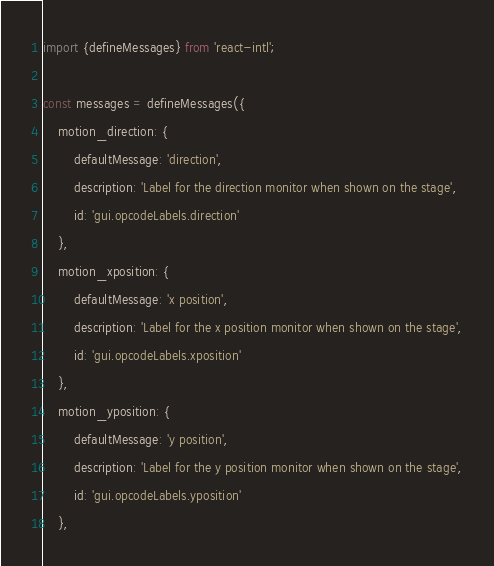<code> <loc_0><loc_0><loc_500><loc_500><_JavaScript_>import {defineMessages} from 'react-intl';

const messages = defineMessages({
    motion_direction: {
        defaultMessage: 'direction',
        description: 'Label for the direction monitor when shown on the stage',
        id: 'gui.opcodeLabels.direction'
    },
    motion_xposition: {
        defaultMessage: 'x position',
        description: 'Label for the x position monitor when shown on the stage',
        id: 'gui.opcodeLabels.xposition'
    },
    motion_yposition: {
        defaultMessage: 'y position',
        description: 'Label for the y position monitor when shown on the stage',
        id: 'gui.opcodeLabels.yposition'
    },
</code> 